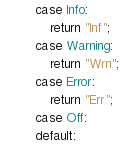Convert code to text. <code><loc_0><loc_0><loc_500><loc_500><_C++_>        case Info:
            return "Inf";
        case Warning:
            return "Wrn";
        case Error:
            return "Err";
        case Off:
        default:</code> 